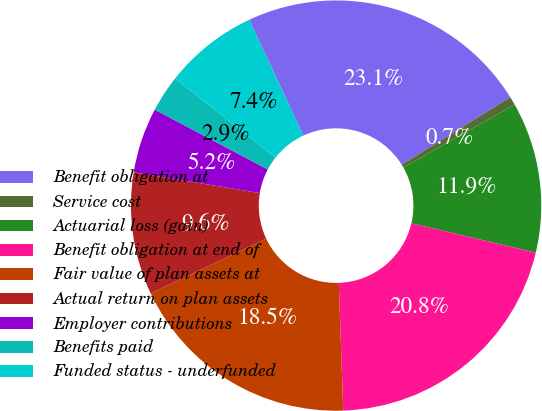<chart> <loc_0><loc_0><loc_500><loc_500><pie_chart><fcel>Benefit obligation at<fcel>Service cost<fcel>Actuarial loss (gain)<fcel>Benefit obligation at end of<fcel>Fair value of plan assets at<fcel>Actual return on plan assets<fcel>Employer contributions<fcel>Benefits paid<fcel>Funded status - underfunded<nl><fcel>23.11%<fcel>0.66%<fcel>11.88%<fcel>20.76%<fcel>18.51%<fcel>9.64%<fcel>5.15%<fcel>2.9%<fcel>7.39%<nl></chart> 